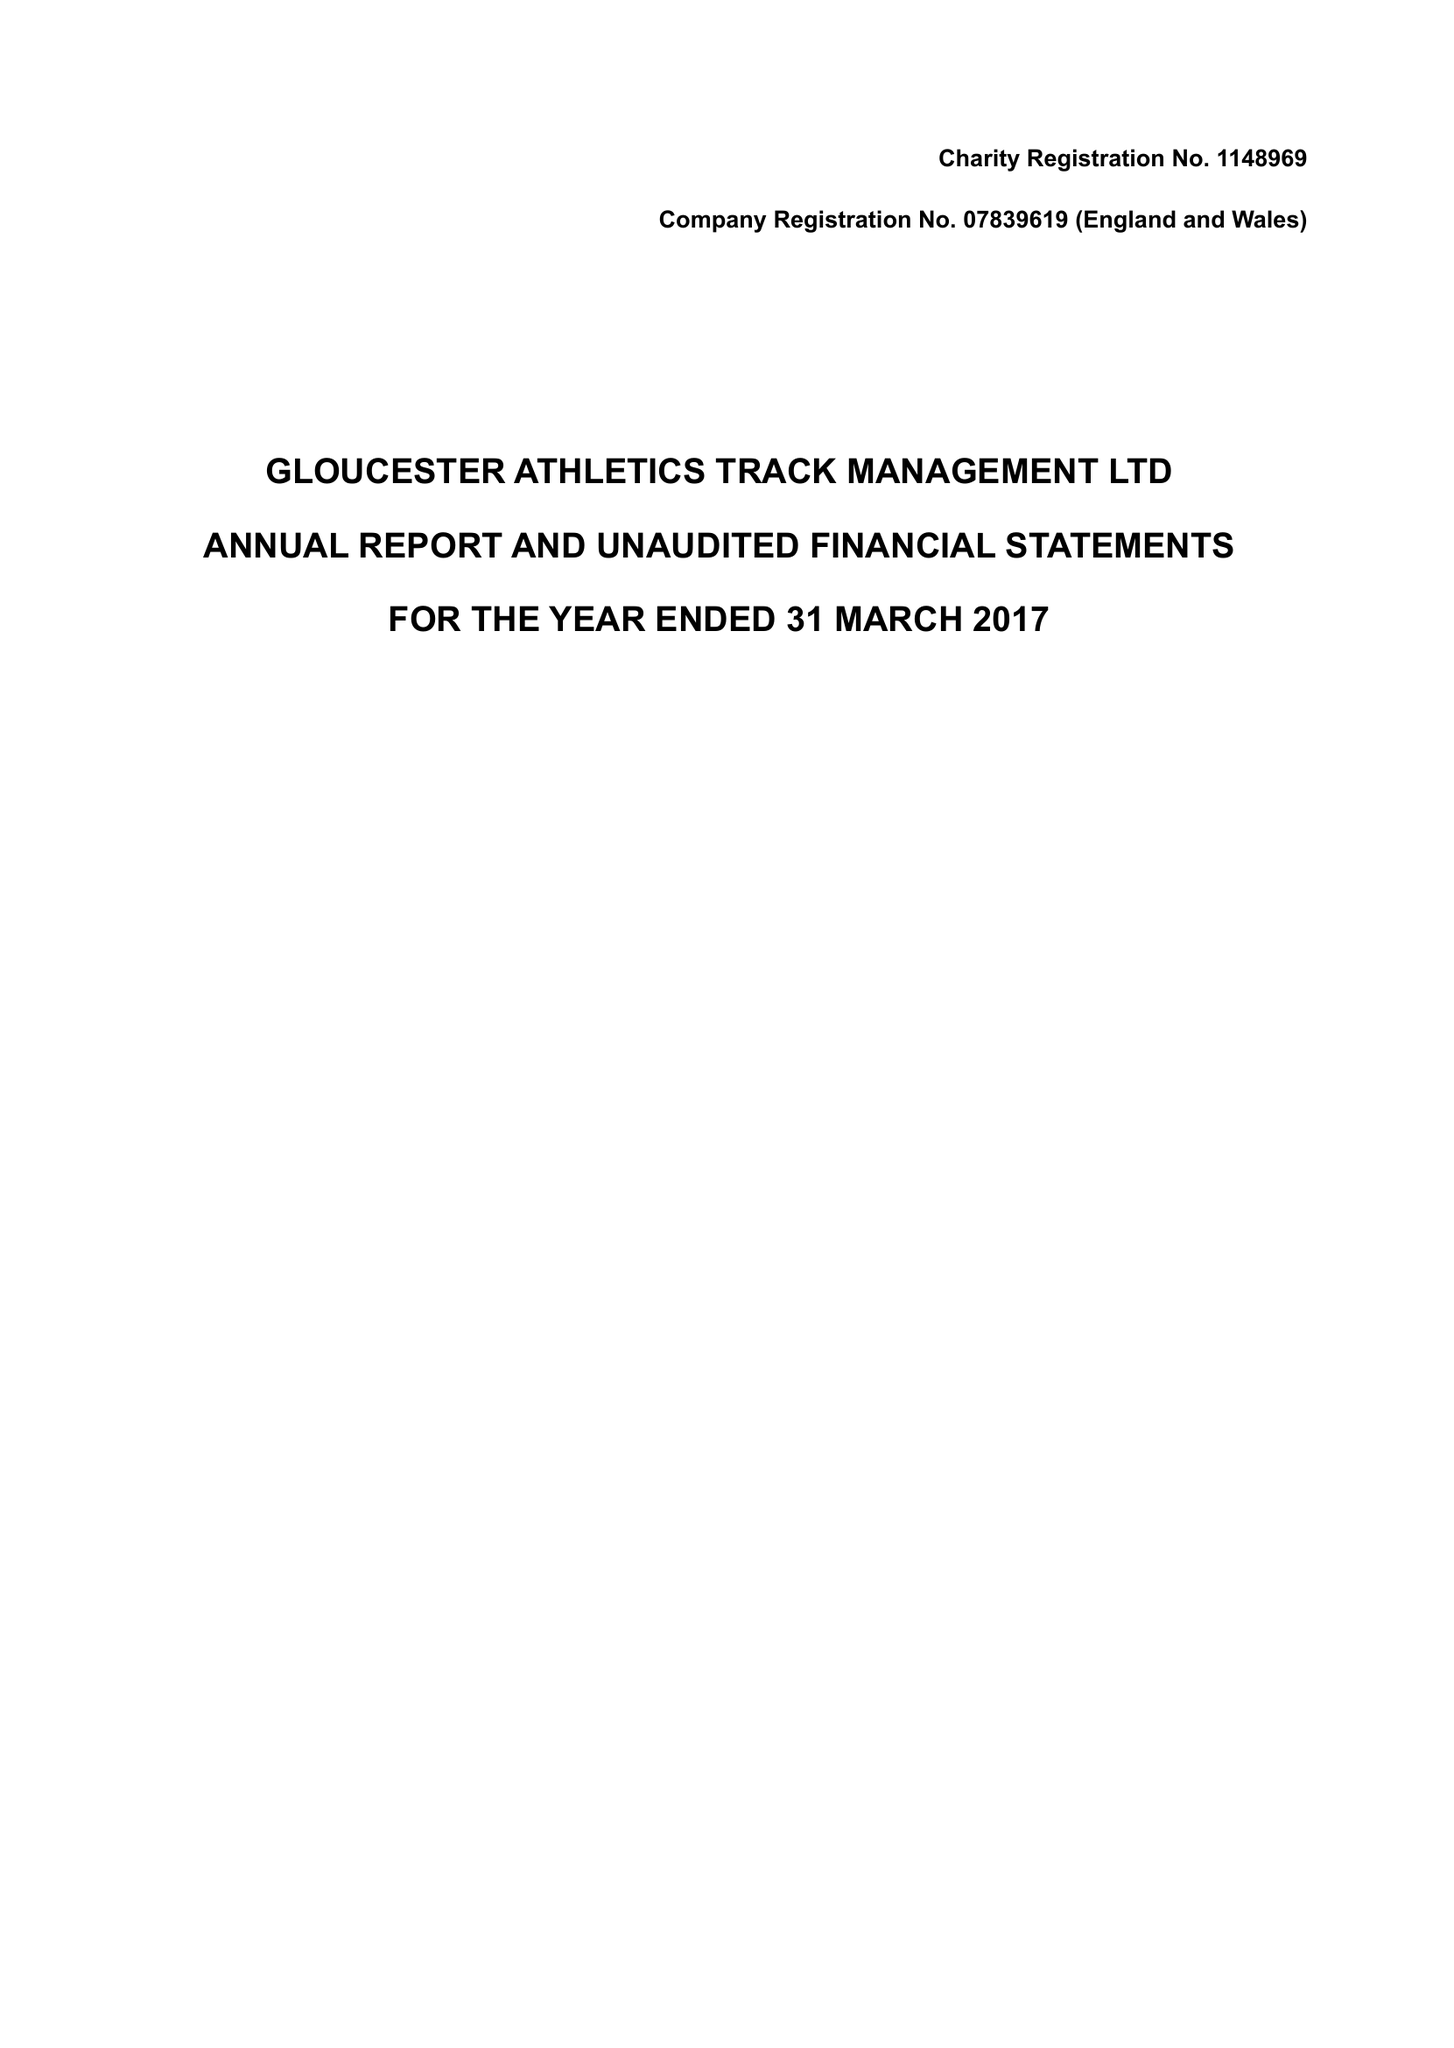What is the value for the charity_number?
Answer the question using a single word or phrase. 1148969 